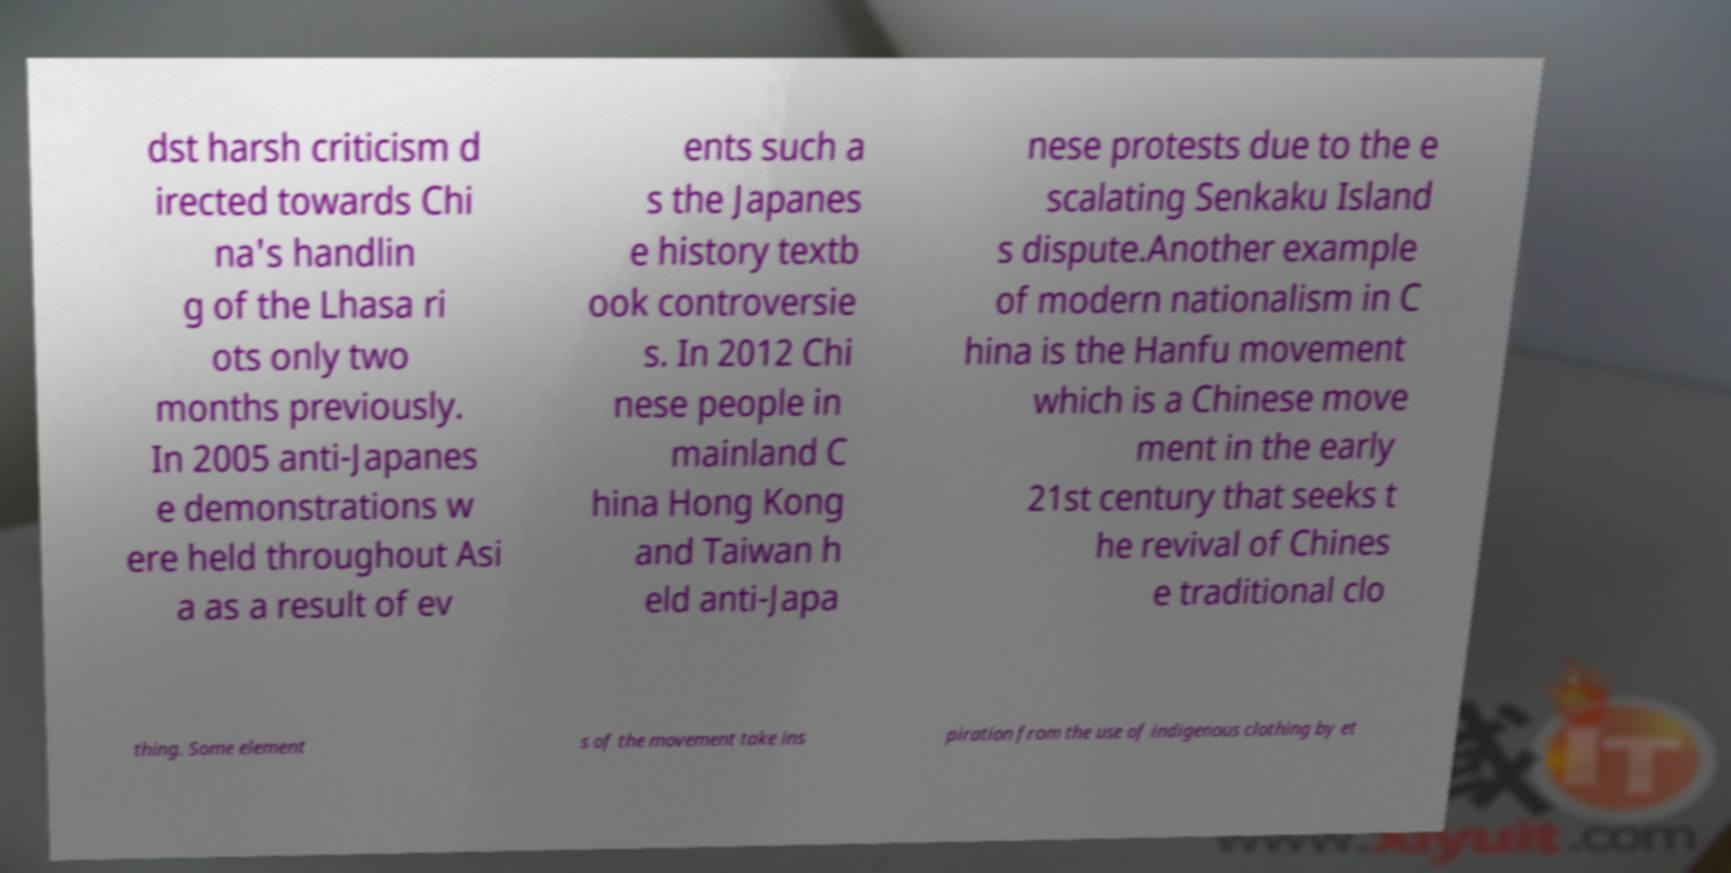Please identify and transcribe the text found in this image. dst harsh criticism d irected towards Chi na's handlin g of the Lhasa ri ots only two months previously. In 2005 anti-Japanes e demonstrations w ere held throughout Asi a as a result of ev ents such a s the Japanes e history textb ook controversie s. In 2012 Chi nese people in mainland C hina Hong Kong and Taiwan h eld anti-Japa nese protests due to the e scalating Senkaku Island s dispute.Another example of modern nationalism in C hina is the Hanfu movement which is a Chinese move ment in the early 21st century that seeks t he revival of Chines e traditional clo thing. Some element s of the movement take ins piration from the use of indigenous clothing by et 